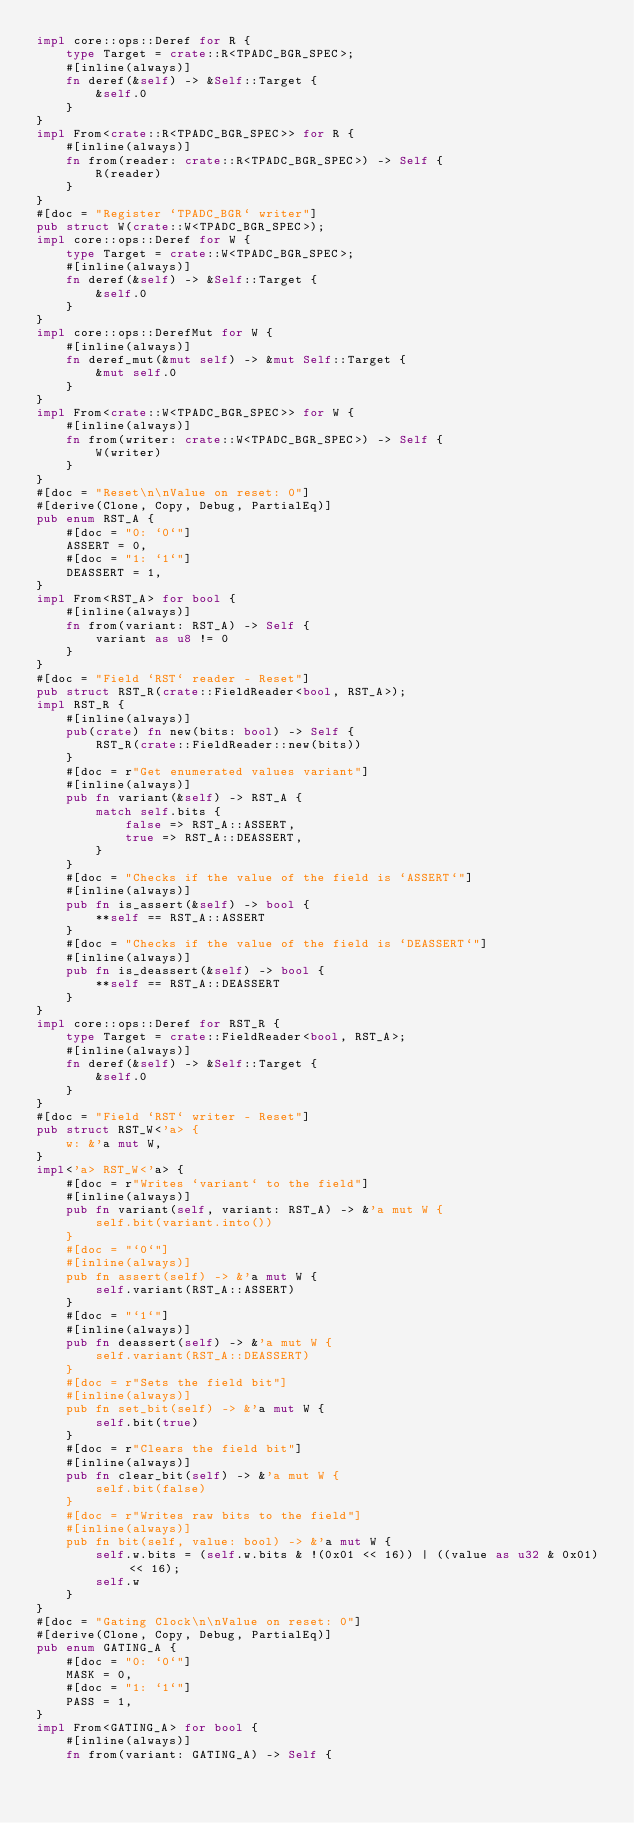<code> <loc_0><loc_0><loc_500><loc_500><_Rust_>impl core::ops::Deref for R {
    type Target = crate::R<TPADC_BGR_SPEC>;
    #[inline(always)]
    fn deref(&self) -> &Self::Target {
        &self.0
    }
}
impl From<crate::R<TPADC_BGR_SPEC>> for R {
    #[inline(always)]
    fn from(reader: crate::R<TPADC_BGR_SPEC>) -> Self {
        R(reader)
    }
}
#[doc = "Register `TPADC_BGR` writer"]
pub struct W(crate::W<TPADC_BGR_SPEC>);
impl core::ops::Deref for W {
    type Target = crate::W<TPADC_BGR_SPEC>;
    #[inline(always)]
    fn deref(&self) -> &Self::Target {
        &self.0
    }
}
impl core::ops::DerefMut for W {
    #[inline(always)]
    fn deref_mut(&mut self) -> &mut Self::Target {
        &mut self.0
    }
}
impl From<crate::W<TPADC_BGR_SPEC>> for W {
    #[inline(always)]
    fn from(writer: crate::W<TPADC_BGR_SPEC>) -> Self {
        W(writer)
    }
}
#[doc = "Reset\n\nValue on reset: 0"]
#[derive(Clone, Copy, Debug, PartialEq)]
pub enum RST_A {
    #[doc = "0: `0`"]
    ASSERT = 0,
    #[doc = "1: `1`"]
    DEASSERT = 1,
}
impl From<RST_A> for bool {
    #[inline(always)]
    fn from(variant: RST_A) -> Self {
        variant as u8 != 0
    }
}
#[doc = "Field `RST` reader - Reset"]
pub struct RST_R(crate::FieldReader<bool, RST_A>);
impl RST_R {
    #[inline(always)]
    pub(crate) fn new(bits: bool) -> Self {
        RST_R(crate::FieldReader::new(bits))
    }
    #[doc = r"Get enumerated values variant"]
    #[inline(always)]
    pub fn variant(&self) -> RST_A {
        match self.bits {
            false => RST_A::ASSERT,
            true => RST_A::DEASSERT,
        }
    }
    #[doc = "Checks if the value of the field is `ASSERT`"]
    #[inline(always)]
    pub fn is_assert(&self) -> bool {
        **self == RST_A::ASSERT
    }
    #[doc = "Checks if the value of the field is `DEASSERT`"]
    #[inline(always)]
    pub fn is_deassert(&self) -> bool {
        **self == RST_A::DEASSERT
    }
}
impl core::ops::Deref for RST_R {
    type Target = crate::FieldReader<bool, RST_A>;
    #[inline(always)]
    fn deref(&self) -> &Self::Target {
        &self.0
    }
}
#[doc = "Field `RST` writer - Reset"]
pub struct RST_W<'a> {
    w: &'a mut W,
}
impl<'a> RST_W<'a> {
    #[doc = r"Writes `variant` to the field"]
    #[inline(always)]
    pub fn variant(self, variant: RST_A) -> &'a mut W {
        self.bit(variant.into())
    }
    #[doc = "`0`"]
    #[inline(always)]
    pub fn assert(self) -> &'a mut W {
        self.variant(RST_A::ASSERT)
    }
    #[doc = "`1`"]
    #[inline(always)]
    pub fn deassert(self) -> &'a mut W {
        self.variant(RST_A::DEASSERT)
    }
    #[doc = r"Sets the field bit"]
    #[inline(always)]
    pub fn set_bit(self) -> &'a mut W {
        self.bit(true)
    }
    #[doc = r"Clears the field bit"]
    #[inline(always)]
    pub fn clear_bit(self) -> &'a mut W {
        self.bit(false)
    }
    #[doc = r"Writes raw bits to the field"]
    #[inline(always)]
    pub fn bit(self, value: bool) -> &'a mut W {
        self.w.bits = (self.w.bits & !(0x01 << 16)) | ((value as u32 & 0x01) << 16);
        self.w
    }
}
#[doc = "Gating Clock\n\nValue on reset: 0"]
#[derive(Clone, Copy, Debug, PartialEq)]
pub enum GATING_A {
    #[doc = "0: `0`"]
    MASK = 0,
    #[doc = "1: `1`"]
    PASS = 1,
}
impl From<GATING_A> for bool {
    #[inline(always)]
    fn from(variant: GATING_A) -> Self {</code> 